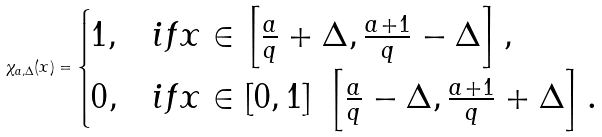Convert formula to latex. <formula><loc_0><loc_0><loc_500><loc_500>\chi _ { a , \Delta } ( x ) = \begin{cases} 1 , & i f x \in \left [ \frac { a } { q } + \Delta , \frac { a + 1 } q - \Delta \right ] , \\ 0 , & i f x \in [ 0 , 1 ] \ \left [ \frac { a } { q } - \Delta , \frac { a + 1 } q + \Delta \right ] . \end{cases}</formula> 